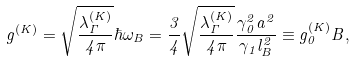Convert formula to latex. <formula><loc_0><loc_0><loc_500><loc_500>g ^ { ( K ) } = \sqrt { \frac { \lambda _ { \Gamma } ^ { ( K ) } } { 4 \pi } } \hbar { \omega } _ { B } = \frac { 3 } { 4 } \sqrt { \frac { \lambda _ { \Gamma } ^ { ( K ) } } { 4 \pi } } \frac { \gamma _ { 0 } ^ { 2 } a ^ { 2 } } { \gamma _ { 1 } l _ { B } ^ { 2 } } \equiv g _ { 0 } ^ { ( K ) } B ,</formula> 